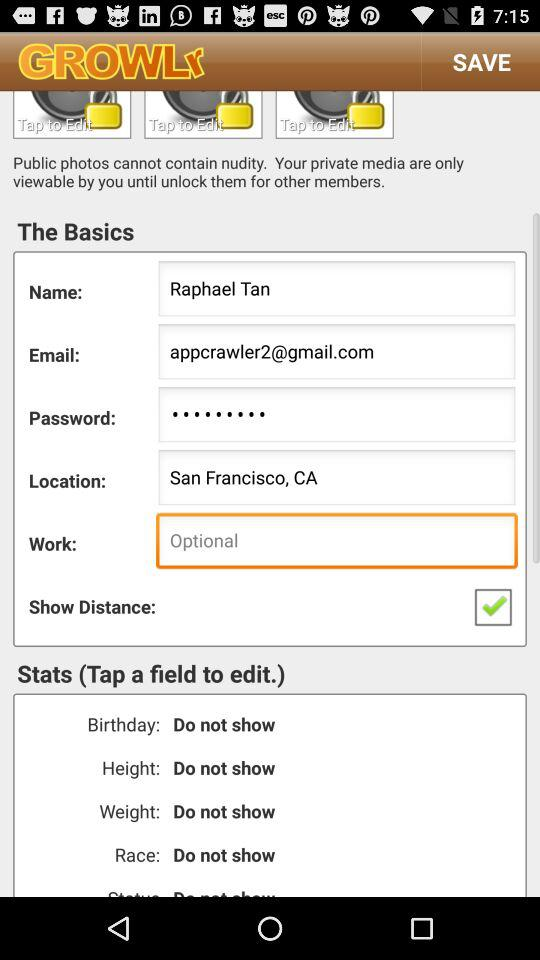What is the email address of the user? The email address of the user is appcrawler2@gmail.com. 